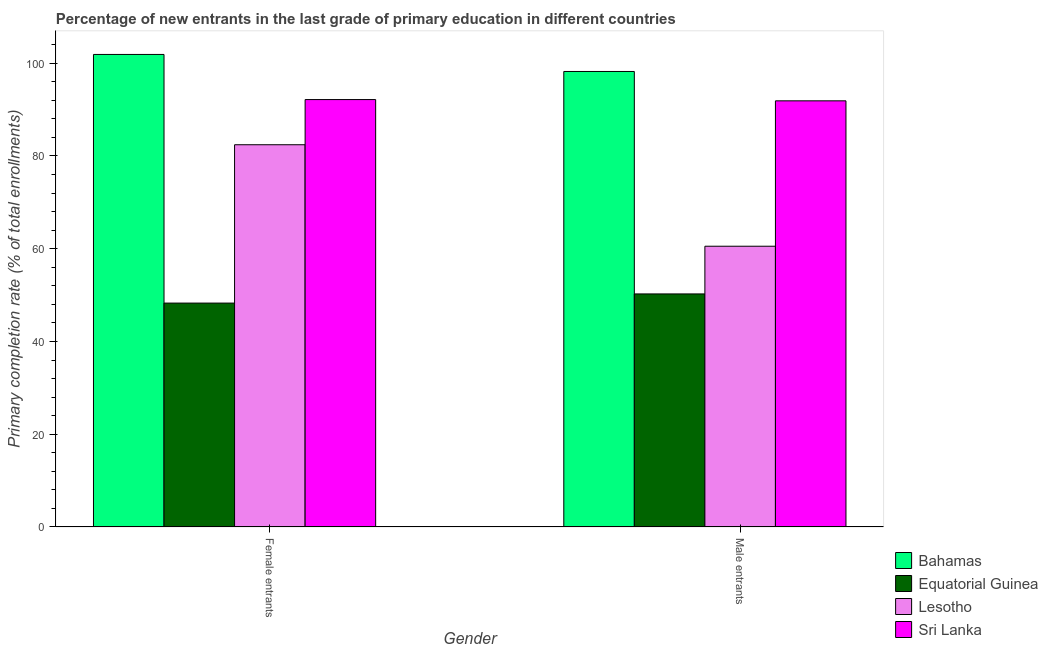Are the number of bars per tick equal to the number of legend labels?
Provide a short and direct response. Yes. Are the number of bars on each tick of the X-axis equal?
Your response must be concise. Yes. How many bars are there on the 1st tick from the right?
Ensure brevity in your answer.  4. What is the label of the 2nd group of bars from the left?
Offer a very short reply. Male entrants. What is the primary completion rate of male entrants in Sri Lanka?
Provide a short and direct response. 91.89. Across all countries, what is the maximum primary completion rate of male entrants?
Offer a terse response. 98.22. Across all countries, what is the minimum primary completion rate of female entrants?
Provide a succinct answer. 48.28. In which country was the primary completion rate of female entrants maximum?
Provide a short and direct response. Bahamas. In which country was the primary completion rate of male entrants minimum?
Your answer should be very brief. Equatorial Guinea. What is the total primary completion rate of female entrants in the graph?
Your response must be concise. 324.76. What is the difference between the primary completion rate of female entrants in Lesotho and that in Bahamas?
Offer a terse response. -19.47. What is the difference between the primary completion rate of female entrants in Sri Lanka and the primary completion rate of male entrants in Equatorial Guinea?
Provide a succinct answer. 41.91. What is the average primary completion rate of male entrants per country?
Provide a short and direct response. 75.23. What is the difference between the primary completion rate of female entrants and primary completion rate of male entrants in Sri Lanka?
Provide a short and direct response. 0.27. In how many countries, is the primary completion rate of female entrants greater than 56 %?
Your response must be concise. 3. What is the ratio of the primary completion rate of male entrants in Equatorial Guinea to that in Bahamas?
Keep it short and to the point. 0.51. In how many countries, is the primary completion rate of male entrants greater than the average primary completion rate of male entrants taken over all countries?
Your answer should be compact. 2. What does the 4th bar from the left in Male entrants represents?
Your answer should be very brief. Sri Lanka. What does the 1st bar from the right in Female entrants represents?
Offer a very short reply. Sri Lanka. How many bars are there?
Provide a succinct answer. 8. Are all the bars in the graph horizontal?
Ensure brevity in your answer.  No. How many countries are there in the graph?
Keep it short and to the point. 4. What is the difference between two consecutive major ticks on the Y-axis?
Make the answer very short. 20. Does the graph contain any zero values?
Your response must be concise. No. Does the graph contain grids?
Make the answer very short. No. Where does the legend appear in the graph?
Give a very brief answer. Bottom right. How are the legend labels stacked?
Your response must be concise. Vertical. What is the title of the graph?
Give a very brief answer. Percentage of new entrants in the last grade of primary education in different countries. Does "Cuba" appear as one of the legend labels in the graph?
Provide a short and direct response. No. What is the label or title of the X-axis?
Ensure brevity in your answer.  Gender. What is the label or title of the Y-axis?
Make the answer very short. Primary completion rate (% of total enrollments). What is the Primary completion rate (% of total enrollments) of Bahamas in Female entrants?
Offer a terse response. 101.89. What is the Primary completion rate (% of total enrollments) in Equatorial Guinea in Female entrants?
Keep it short and to the point. 48.28. What is the Primary completion rate (% of total enrollments) of Lesotho in Female entrants?
Your response must be concise. 82.43. What is the Primary completion rate (% of total enrollments) of Sri Lanka in Female entrants?
Make the answer very short. 92.16. What is the Primary completion rate (% of total enrollments) in Bahamas in Male entrants?
Offer a terse response. 98.22. What is the Primary completion rate (% of total enrollments) of Equatorial Guinea in Male entrants?
Your answer should be very brief. 50.26. What is the Primary completion rate (% of total enrollments) in Lesotho in Male entrants?
Offer a terse response. 60.54. What is the Primary completion rate (% of total enrollments) in Sri Lanka in Male entrants?
Provide a short and direct response. 91.89. Across all Gender, what is the maximum Primary completion rate (% of total enrollments) of Bahamas?
Make the answer very short. 101.89. Across all Gender, what is the maximum Primary completion rate (% of total enrollments) in Equatorial Guinea?
Make the answer very short. 50.26. Across all Gender, what is the maximum Primary completion rate (% of total enrollments) of Lesotho?
Offer a very short reply. 82.43. Across all Gender, what is the maximum Primary completion rate (% of total enrollments) in Sri Lanka?
Your response must be concise. 92.16. Across all Gender, what is the minimum Primary completion rate (% of total enrollments) of Bahamas?
Your response must be concise. 98.22. Across all Gender, what is the minimum Primary completion rate (% of total enrollments) in Equatorial Guinea?
Your answer should be compact. 48.28. Across all Gender, what is the minimum Primary completion rate (% of total enrollments) of Lesotho?
Offer a terse response. 60.54. Across all Gender, what is the minimum Primary completion rate (% of total enrollments) of Sri Lanka?
Keep it short and to the point. 91.89. What is the total Primary completion rate (% of total enrollments) of Bahamas in the graph?
Offer a terse response. 200.12. What is the total Primary completion rate (% of total enrollments) of Equatorial Guinea in the graph?
Make the answer very short. 98.54. What is the total Primary completion rate (% of total enrollments) in Lesotho in the graph?
Make the answer very short. 142.97. What is the total Primary completion rate (% of total enrollments) of Sri Lanka in the graph?
Provide a short and direct response. 184.06. What is the difference between the Primary completion rate (% of total enrollments) of Bahamas in Female entrants and that in Male entrants?
Your answer should be very brief. 3.67. What is the difference between the Primary completion rate (% of total enrollments) of Equatorial Guinea in Female entrants and that in Male entrants?
Give a very brief answer. -1.98. What is the difference between the Primary completion rate (% of total enrollments) in Lesotho in Female entrants and that in Male entrants?
Provide a short and direct response. 21.88. What is the difference between the Primary completion rate (% of total enrollments) of Sri Lanka in Female entrants and that in Male entrants?
Your answer should be very brief. 0.27. What is the difference between the Primary completion rate (% of total enrollments) in Bahamas in Female entrants and the Primary completion rate (% of total enrollments) in Equatorial Guinea in Male entrants?
Give a very brief answer. 51.64. What is the difference between the Primary completion rate (% of total enrollments) of Bahamas in Female entrants and the Primary completion rate (% of total enrollments) of Lesotho in Male entrants?
Give a very brief answer. 41.35. What is the difference between the Primary completion rate (% of total enrollments) of Bahamas in Female entrants and the Primary completion rate (% of total enrollments) of Sri Lanka in Male entrants?
Keep it short and to the point. 10. What is the difference between the Primary completion rate (% of total enrollments) in Equatorial Guinea in Female entrants and the Primary completion rate (% of total enrollments) in Lesotho in Male entrants?
Your answer should be compact. -12.26. What is the difference between the Primary completion rate (% of total enrollments) in Equatorial Guinea in Female entrants and the Primary completion rate (% of total enrollments) in Sri Lanka in Male entrants?
Your answer should be very brief. -43.61. What is the difference between the Primary completion rate (% of total enrollments) in Lesotho in Female entrants and the Primary completion rate (% of total enrollments) in Sri Lanka in Male entrants?
Offer a very short reply. -9.47. What is the average Primary completion rate (% of total enrollments) in Bahamas per Gender?
Provide a short and direct response. 100.06. What is the average Primary completion rate (% of total enrollments) in Equatorial Guinea per Gender?
Your answer should be very brief. 49.27. What is the average Primary completion rate (% of total enrollments) in Lesotho per Gender?
Your answer should be very brief. 71.48. What is the average Primary completion rate (% of total enrollments) in Sri Lanka per Gender?
Ensure brevity in your answer.  92.03. What is the difference between the Primary completion rate (% of total enrollments) of Bahamas and Primary completion rate (% of total enrollments) of Equatorial Guinea in Female entrants?
Keep it short and to the point. 53.61. What is the difference between the Primary completion rate (% of total enrollments) in Bahamas and Primary completion rate (% of total enrollments) in Lesotho in Female entrants?
Provide a short and direct response. 19.47. What is the difference between the Primary completion rate (% of total enrollments) of Bahamas and Primary completion rate (% of total enrollments) of Sri Lanka in Female entrants?
Your response must be concise. 9.73. What is the difference between the Primary completion rate (% of total enrollments) in Equatorial Guinea and Primary completion rate (% of total enrollments) in Lesotho in Female entrants?
Provide a short and direct response. -34.14. What is the difference between the Primary completion rate (% of total enrollments) in Equatorial Guinea and Primary completion rate (% of total enrollments) in Sri Lanka in Female entrants?
Give a very brief answer. -43.88. What is the difference between the Primary completion rate (% of total enrollments) of Lesotho and Primary completion rate (% of total enrollments) of Sri Lanka in Female entrants?
Make the answer very short. -9.74. What is the difference between the Primary completion rate (% of total enrollments) in Bahamas and Primary completion rate (% of total enrollments) in Equatorial Guinea in Male entrants?
Make the answer very short. 47.97. What is the difference between the Primary completion rate (% of total enrollments) of Bahamas and Primary completion rate (% of total enrollments) of Lesotho in Male entrants?
Make the answer very short. 37.68. What is the difference between the Primary completion rate (% of total enrollments) in Bahamas and Primary completion rate (% of total enrollments) in Sri Lanka in Male entrants?
Provide a succinct answer. 6.33. What is the difference between the Primary completion rate (% of total enrollments) of Equatorial Guinea and Primary completion rate (% of total enrollments) of Lesotho in Male entrants?
Offer a terse response. -10.29. What is the difference between the Primary completion rate (% of total enrollments) in Equatorial Guinea and Primary completion rate (% of total enrollments) in Sri Lanka in Male entrants?
Offer a very short reply. -41.64. What is the difference between the Primary completion rate (% of total enrollments) in Lesotho and Primary completion rate (% of total enrollments) in Sri Lanka in Male entrants?
Keep it short and to the point. -31.35. What is the ratio of the Primary completion rate (% of total enrollments) in Bahamas in Female entrants to that in Male entrants?
Your answer should be very brief. 1.04. What is the ratio of the Primary completion rate (% of total enrollments) of Equatorial Guinea in Female entrants to that in Male entrants?
Keep it short and to the point. 0.96. What is the ratio of the Primary completion rate (% of total enrollments) in Lesotho in Female entrants to that in Male entrants?
Provide a succinct answer. 1.36. What is the ratio of the Primary completion rate (% of total enrollments) in Sri Lanka in Female entrants to that in Male entrants?
Provide a succinct answer. 1. What is the difference between the highest and the second highest Primary completion rate (% of total enrollments) of Bahamas?
Ensure brevity in your answer.  3.67. What is the difference between the highest and the second highest Primary completion rate (% of total enrollments) in Equatorial Guinea?
Your response must be concise. 1.98. What is the difference between the highest and the second highest Primary completion rate (% of total enrollments) in Lesotho?
Keep it short and to the point. 21.88. What is the difference between the highest and the second highest Primary completion rate (% of total enrollments) in Sri Lanka?
Your answer should be very brief. 0.27. What is the difference between the highest and the lowest Primary completion rate (% of total enrollments) in Bahamas?
Your answer should be very brief. 3.67. What is the difference between the highest and the lowest Primary completion rate (% of total enrollments) of Equatorial Guinea?
Make the answer very short. 1.98. What is the difference between the highest and the lowest Primary completion rate (% of total enrollments) in Lesotho?
Make the answer very short. 21.88. What is the difference between the highest and the lowest Primary completion rate (% of total enrollments) of Sri Lanka?
Give a very brief answer. 0.27. 